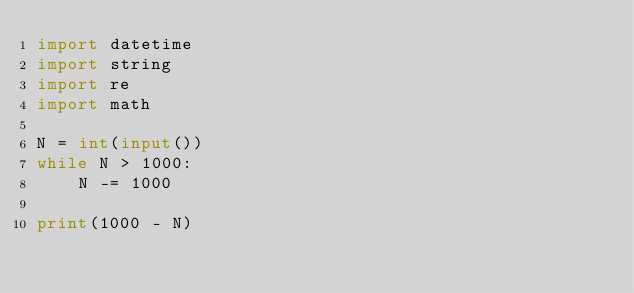<code> <loc_0><loc_0><loc_500><loc_500><_Python_>import datetime
import string
import re
import math

N = int(input())
while N > 1000:
    N -= 1000

print(1000 - N)
</code> 